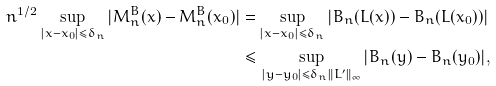<formula> <loc_0><loc_0><loc_500><loc_500>n ^ { 1 / 2 } \sup _ { | x - x _ { 0 } | \leq \delta _ { n } } | M _ { n } ^ { B } ( x ) - M _ { n } ^ { B } ( x _ { 0 } ) | & = \sup _ { | x - x _ { 0 } | \leq \delta _ { n } } | B _ { n } ( L ( x ) ) - B _ { n } ( L ( x _ { 0 } ) ) | \\ & \leq \sup _ { | y - y _ { 0 } | \leq \delta _ { n } \| L ^ { \prime } \| _ { \infty } } | B _ { n } ( y ) - B _ { n } ( y _ { 0 } ) | ,</formula> 